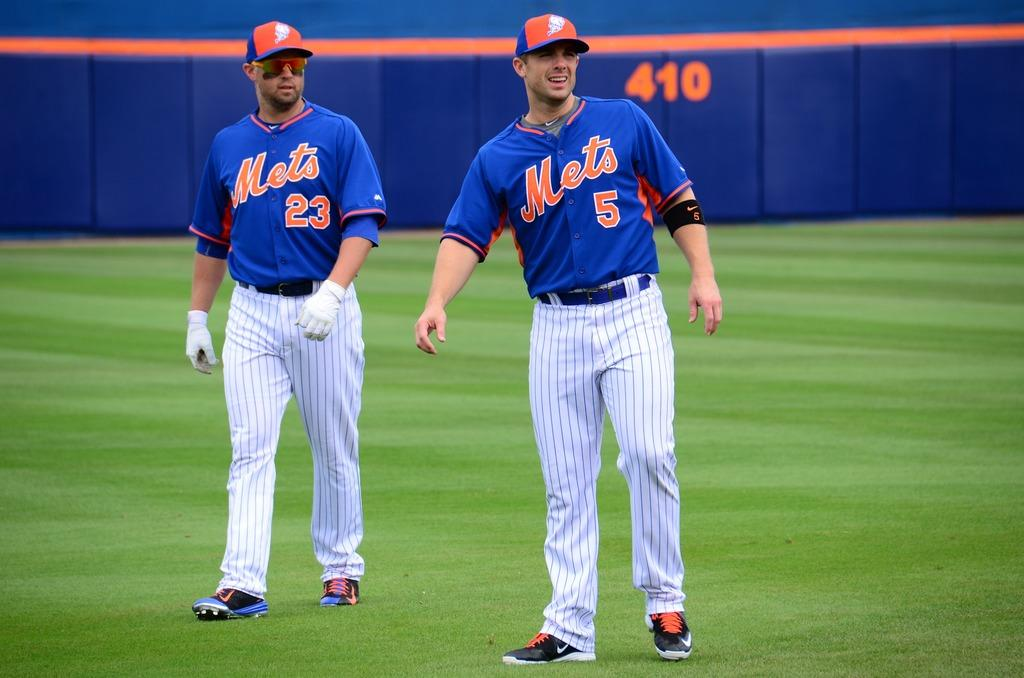Provide a one-sentence caption for the provided image. Mets players wearing shirts numbered 23 and 5 walk across the outfield together. 